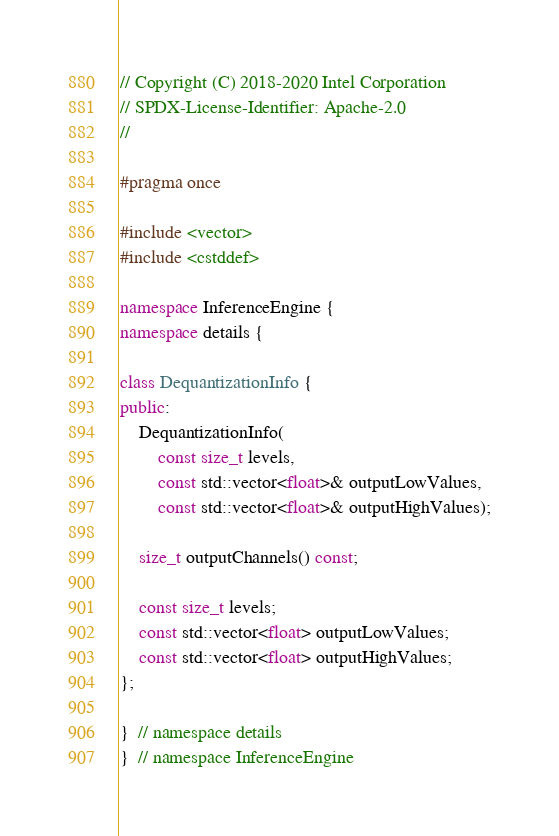Convert code to text. <code><loc_0><loc_0><loc_500><loc_500><_C++_>// Copyright (C) 2018-2020 Intel Corporation
// SPDX-License-Identifier: Apache-2.0
//

#pragma once

#include <vector>
#include <cstddef>

namespace InferenceEngine {
namespace details {

class DequantizationInfo {
public:
    DequantizationInfo(
        const size_t levels,
        const std::vector<float>& outputLowValues,
        const std::vector<float>& outputHighValues);

    size_t outputChannels() const;

    const size_t levels;
    const std::vector<float> outputLowValues;
    const std::vector<float> outputHighValues;
};

}  // namespace details
}  // namespace InferenceEngine
</code> 